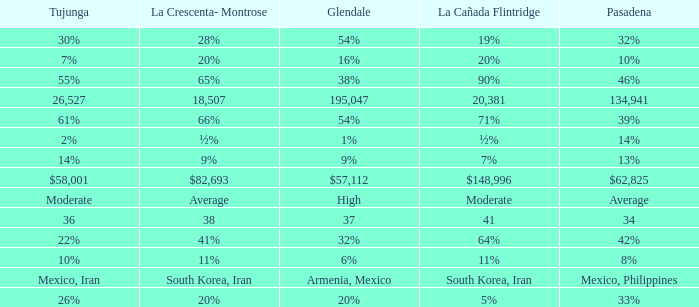When La Crescenta-Montrose has 66%, what is Tujunga? 61%. 